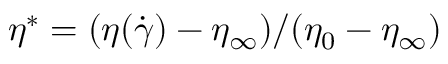<formula> <loc_0><loc_0><loc_500><loc_500>\eta ^ { * } = ( \eta ( \dot { \gamma } ) - \eta _ { \infty } ) / ( \eta _ { 0 } - \eta _ { \infty } )</formula> 